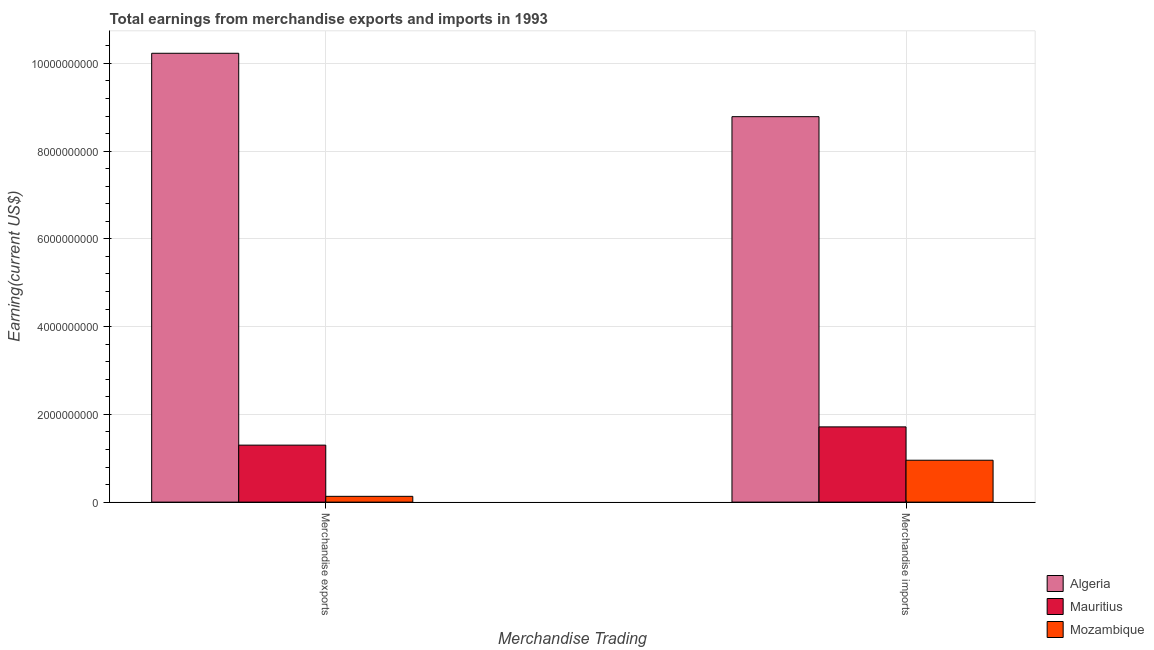How many groups of bars are there?
Offer a very short reply. 2. Are the number of bars per tick equal to the number of legend labels?
Your answer should be compact. Yes. How many bars are there on the 1st tick from the left?
Your response must be concise. 3. What is the label of the 1st group of bars from the left?
Make the answer very short. Merchandise exports. What is the earnings from merchandise imports in Mauritius?
Your answer should be very brief. 1.72e+09. Across all countries, what is the maximum earnings from merchandise imports?
Offer a terse response. 8.78e+09. Across all countries, what is the minimum earnings from merchandise imports?
Your answer should be compact. 9.55e+08. In which country was the earnings from merchandise imports maximum?
Provide a succinct answer. Algeria. In which country was the earnings from merchandise imports minimum?
Make the answer very short. Mozambique. What is the total earnings from merchandise exports in the graph?
Your response must be concise. 1.17e+1. What is the difference between the earnings from merchandise exports in Mozambique and that in Mauritius?
Offer a very short reply. -1.17e+09. What is the difference between the earnings from merchandise imports in Algeria and the earnings from merchandise exports in Mozambique?
Offer a terse response. 8.65e+09. What is the average earnings from merchandise imports per country?
Provide a succinct answer. 3.82e+09. What is the difference between the earnings from merchandise imports and earnings from merchandise exports in Algeria?
Ensure brevity in your answer.  -1.44e+09. In how many countries, is the earnings from merchandise imports greater than 6400000000 US$?
Offer a very short reply. 1. What is the ratio of the earnings from merchandise imports in Mozambique to that in Mauritius?
Provide a succinct answer. 0.56. Is the earnings from merchandise exports in Mozambique less than that in Algeria?
Ensure brevity in your answer.  Yes. In how many countries, is the earnings from merchandise imports greater than the average earnings from merchandise imports taken over all countries?
Offer a terse response. 1. What does the 1st bar from the left in Merchandise exports represents?
Ensure brevity in your answer.  Algeria. What does the 3rd bar from the right in Merchandise exports represents?
Your answer should be very brief. Algeria. How many bars are there?
Offer a very short reply. 6. Are all the bars in the graph horizontal?
Your answer should be very brief. No. What is the difference between two consecutive major ticks on the Y-axis?
Your response must be concise. 2.00e+09. Does the graph contain any zero values?
Ensure brevity in your answer.  No. How many legend labels are there?
Make the answer very short. 3. How are the legend labels stacked?
Your answer should be very brief. Vertical. What is the title of the graph?
Give a very brief answer. Total earnings from merchandise exports and imports in 1993. What is the label or title of the X-axis?
Offer a terse response. Merchandise Trading. What is the label or title of the Y-axis?
Provide a succinct answer. Earning(current US$). What is the Earning(current US$) of Algeria in Merchandise exports?
Offer a terse response. 1.02e+1. What is the Earning(current US$) of Mauritius in Merchandise exports?
Ensure brevity in your answer.  1.30e+09. What is the Earning(current US$) of Mozambique in Merchandise exports?
Provide a succinct answer. 1.32e+08. What is the Earning(current US$) in Algeria in Merchandise imports?
Provide a short and direct response. 8.78e+09. What is the Earning(current US$) in Mauritius in Merchandise imports?
Your answer should be compact. 1.72e+09. What is the Earning(current US$) in Mozambique in Merchandise imports?
Ensure brevity in your answer.  9.55e+08. Across all Merchandise Trading, what is the maximum Earning(current US$) of Algeria?
Provide a succinct answer. 1.02e+1. Across all Merchandise Trading, what is the maximum Earning(current US$) of Mauritius?
Offer a terse response. 1.72e+09. Across all Merchandise Trading, what is the maximum Earning(current US$) in Mozambique?
Your answer should be compact. 9.55e+08. Across all Merchandise Trading, what is the minimum Earning(current US$) in Algeria?
Offer a very short reply. 8.78e+09. Across all Merchandise Trading, what is the minimum Earning(current US$) of Mauritius?
Offer a terse response. 1.30e+09. Across all Merchandise Trading, what is the minimum Earning(current US$) in Mozambique?
Make the answer very short. 1.32e+08. What is the total Earning(current US$) in Algeria in the graph?
Ensure brevity in your answer.  1.90e+1. What is the total Earning(current US$) of Mauritius in the graph?
Give a very brief answer. 3.01e+09. What is the total Earning(current US$) in Mozambique in the graph?
Offer a terse response. 1.09e+09. What is the difference between the Earning(current US$) of Algeria in Merchandise exports and that in Merchandise imports?
Offer a very short reply. 1.44e+09. What is the difference between the Earning(current US$) in Mauritius in Merchandise exports and that in Merchandise imports?
Give a very brief answer. -4.16e+08. What is the difference between the Earning(current US$) in Mozambique in Merchandise exports and that in Merchandise imports?
Ensure brevity in your answer.  -8.23e+08. What is the difference between the Earning(current US$) in Algeria in Merchandise exports and the Earning(current US$) in Mauritius in Merchandise imports?
Make the answer very short. 8.52e+09. What is the difference between the Earning(current US$) in Algeria in Merchandise exports and the Earning(current US$) in Mozambique in Merchandise imports?
Make the answer very short. 9.28e+09. What is the difference between the Earning(current US$) of Mauritius in Merchandise exports and the Earning(current US$) of Mozambique in Merchandise imports?
Ensure brevity in your answer.  3.44e+08. What is the average Earning(current US$) of Algeria per Merchandise Trading?
Make the answer very short. 9.51e+09. What is the average Earning(current US$) of Mauritius per Merchandise Trading?
Offer a terse response. 1.51e+09. What is the average Earning(current US$) in Mozambique per Merchandise Trading?
Give a very brief answer. 5.44e+08. What is the difference between the Earning(current US$) in Algeria and Earning(current US$) in Mauritius in Merchandise exports?
Keep it short and to the point. 8.93e+09. What is the difference between the Earning(current US$) of Algeria and Earning(current US$) of Mozambique in Merchandise exports?
Your answer should be very brief. 1.01e+1. What is the difference between the Earning(current US$) in Mauritius and Earning(current US$) in Mozambique in Merchandise exports?
Give a very brief answer. 1.17e+09. What is the difference between the Earning(current US$) in Algeria and Earning(current US$) in Mauritius in Merchandise imports?
Provide a succinct answer. 7.07e+09. What is the difference between the Earning(current US$) in Algeria and Earning(current US$) in Mozambique in Merchandise imports?
Provide a short and direct response. 7.83e+09. What is the difference between the Earning(current US$) of Mauritius and Earning(current US$) of Mozambique in Merchandise imports?
Offer a terse response. 7.60e+08. What is the ratio of the Earning(current US$) of Algeria in Merchandise exports to that in Merchandise imports?
Provide a succinct answer. 1.16. What is the ratio of the Earning(current US$) of Mauritius in Merchandise exports to that in Merchandise imports?
Offer a very short reply. 0.76. What is the ratio of the Earning(current US$) in Mozambique in Merchandise exports to that in Merchandise imports?
Provide a succinct answer. 0.14. What is the difference between the highest and the second highest Earning(current US$) of Algeria?
Make the answer very short. 1.44e+09. What is the difference between the highest and the second highest Earning(current US$) in Mauritius?
Keep it short and to the point. 4.16e+08. What is the difference between the highest and the second highest Earning(current US$) of Mozambique?
Provide a short and direct response. 8.23e+08. What is the difference between the highest and the lowest Earning(current US$) in Algeria?
Provide a short and direct response. 1.44e+09. What is the difference between the highest and the lowest Earning(current US$) in Mauritius?
Give a very brief answer. 4.16e+08. What is the difference between the highest and the lowest Earning(current US$) of Mozambique?
Offer a terse response. 8.23e+08. 